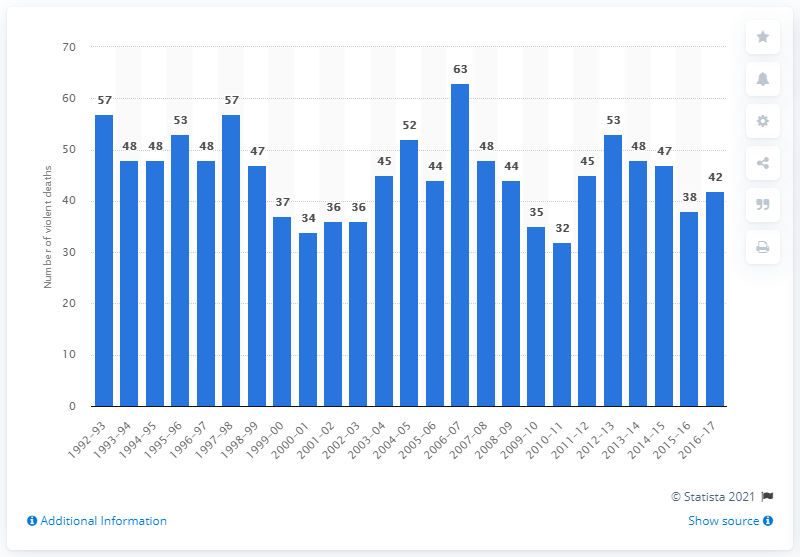Mention a couple of crucial points in this snapshot. In the 2016-2017 school year, a total of 42 people were killed or committed suicide in elementary, middle, and high schools. 